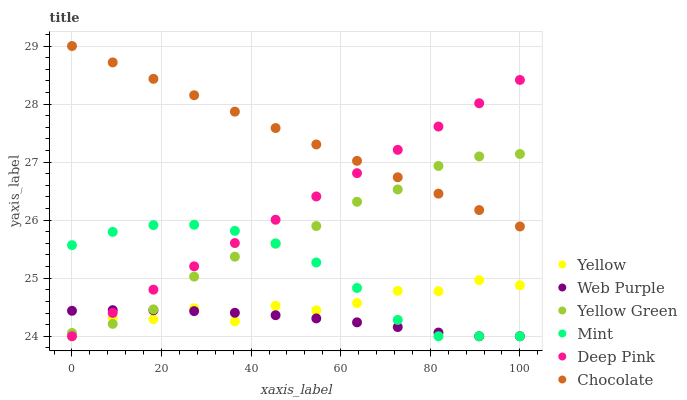Does Web Purple have the minimum area under the curve?
Answer yes or no. Yes. Does Chocolate have the maximum area under the curve?
Answer yes or no. Yes. Does Yellow Green have the minimum area under the curve?
Answer yes or no. No. Does Yellow Green have the maximum area under the curve?
Answer yes or no. No. Is Deep Pink the smoothest?
Answer yes or no. Yes. Is Yellow the roughest?
Answer yes or no. Yes. Is Yellow Green the smoothest?
Answer yes or no. No. Is Yellow Green the roughest?
Answer yes or no. No. Does Deep Pink have the lowest value?
Answer yes or no. Yes. Does Yellow Green have the lowest value?
Answer yes or no. No. Does Chocolate have the highest value?
Answer yes or no. Yes. Does Yellow Green have the highest value?
Answer yes or no. No. Is Yellow less than Chocolate?
Answer yes or no. Yes. Is Chocolate greater than Mint?
Answer yes or no. Yes. Does Web Purple intersect Mint?
Answer yes or no. Yes. Is Web Purple less than Mint?
Answer yes or no. No. Is Web Purple greater than Mint?
Answer yes or no. No. Does Yellow intersect Chocolate?
Answer yes or no. No. 